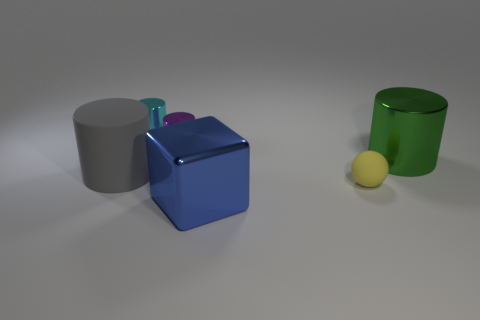Imagine these objects are part of a game. What kind of game could it be and how would it be played? These objects could be part of a physics-based puzzle game. Each object might have a different weight and material property, and the player's objective could be to strategically stack or arrange them to achieve a specific configuration without toppling over, possibly within a time limit to add challenge. 